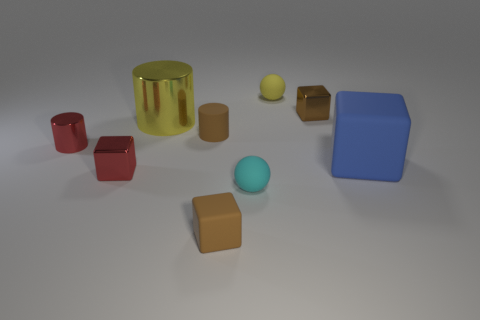There is a matte thing that is the same color as the big cylinder; what shape is it?
Your answer should be compact. Sphere. What color is the small rubber ball to the left of the small rubber sphere behind the tiny ball in front of the brown metallic block?
Provide a short and direct response. Cyan. Is the shape of the brown metal thing behind the rubber cylinder the same as  the large rubber thing?
Your response must be concise. Yes. The rubber cube that is the same size as the cyan ball is what color?
Your answer should be very brief. Brown. How many small rubber balls are there?
Make the answer very short. 2. Does the small ball that is in front of the large yellow shiny thing have the same material as the small yellow ball?
Make the answer very short. Yes. There is a cube that is to the right of the cyan rubber sphere and in front of the small brown cylinder; what is its material?
Your answer should be compact. Rubber. What material is the tiny cube behind the tiny matte thing on the left side of the tiny brown matte block?
Provide a short and direct response. Metal. What size is the matte block that is on the left side of the yellow rubber thing on the right side of the sphere that is in front of the brown metallic cube?
Your answer should be compact. Small. How many tiny cubes are the same material as the large cylinder?
Provide a succinct answer. 2. 